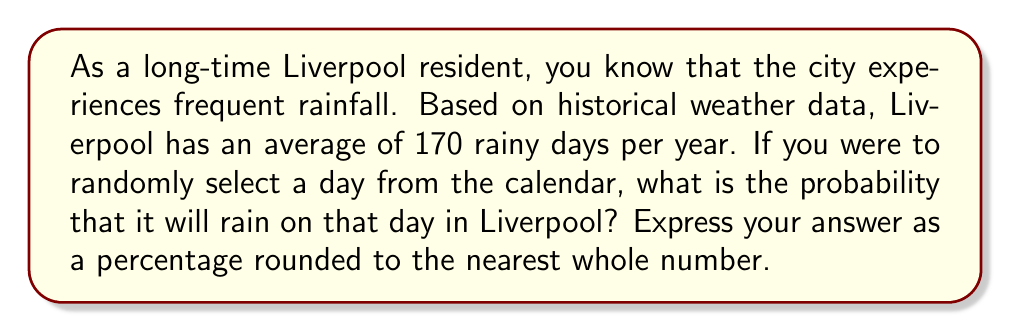Can you solve this math problem? To solve this problem, we need to follow these steps:

1. Identify the total number of days in a year:
   $$ \text{Total days} = 365 $$

2. Use the given information about the average number of rainy days:
   $$ \text{Rainy days} = 170 $$

3. Calculate the probability of rain on a given day:
   $$ P(\text{Rain}) = \frac{\text{Rainy days}}{\text{Total days}} $$
   
   $$ P(\text{Rain}) = \frac{170}{365} $$

4. Convert the probability to a percentage:
   $$ P(\text{Rain}) \% = \frac{170}{365} \times 100\% $$
   
   $$ P(\text{Rain}) \% = 46.5753424...\% $$

5. Round the percentage to the nearest whole number:
   $$ P(\text{Rain}) \% \approx 47\% $$

Therefore, the probability of rain on a randomly selected day in Liverpool is approximately 47%.
Answer: 47% 